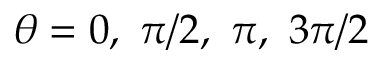<formula> <loc_0><loc_0><loc_500><loc_500>\theta = 0 , \ \pi / 2 , \ \pi , \ 3 \pi / 2</formula> 